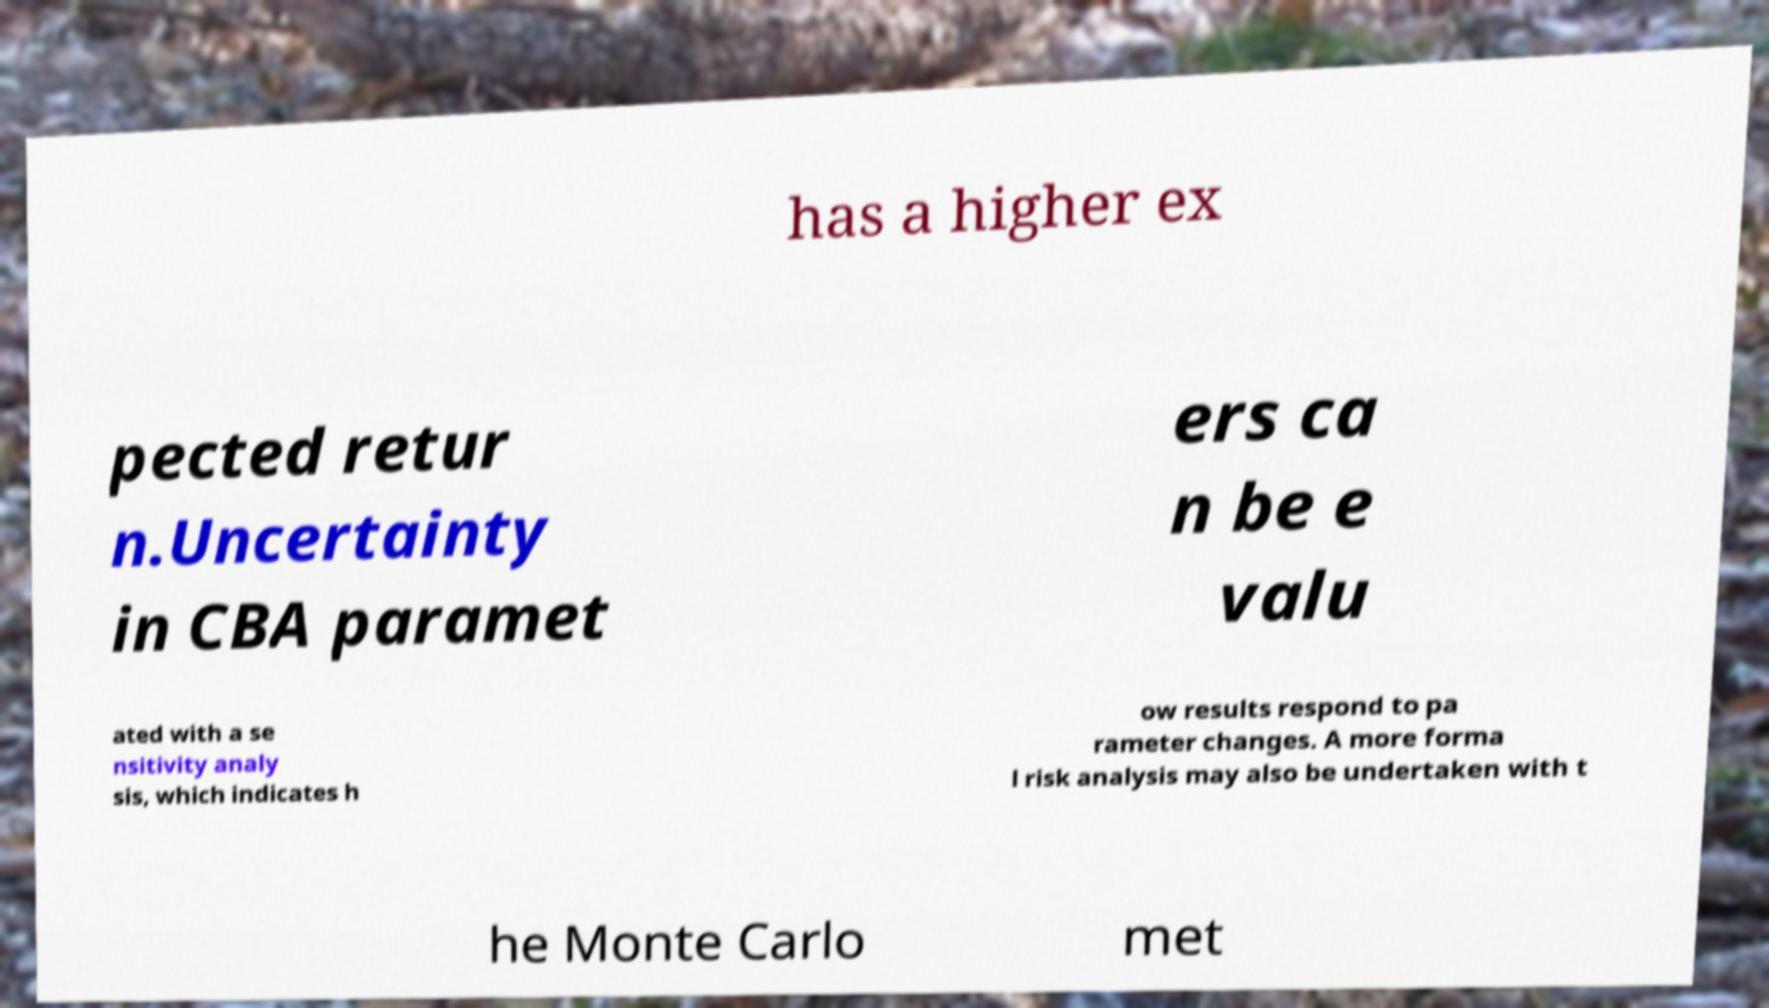What messages or text are displayed in this image? I need them in a readable, typed format. has a higher ex pected retur n.Uncertainty in CBA paramet ers ca n be e valu ated with a se nsitivity analy sis, which indicates h ow results respond to pa rameter changes. A more forma l risk analysis may also be undertaken with t he Monte Carlo met 